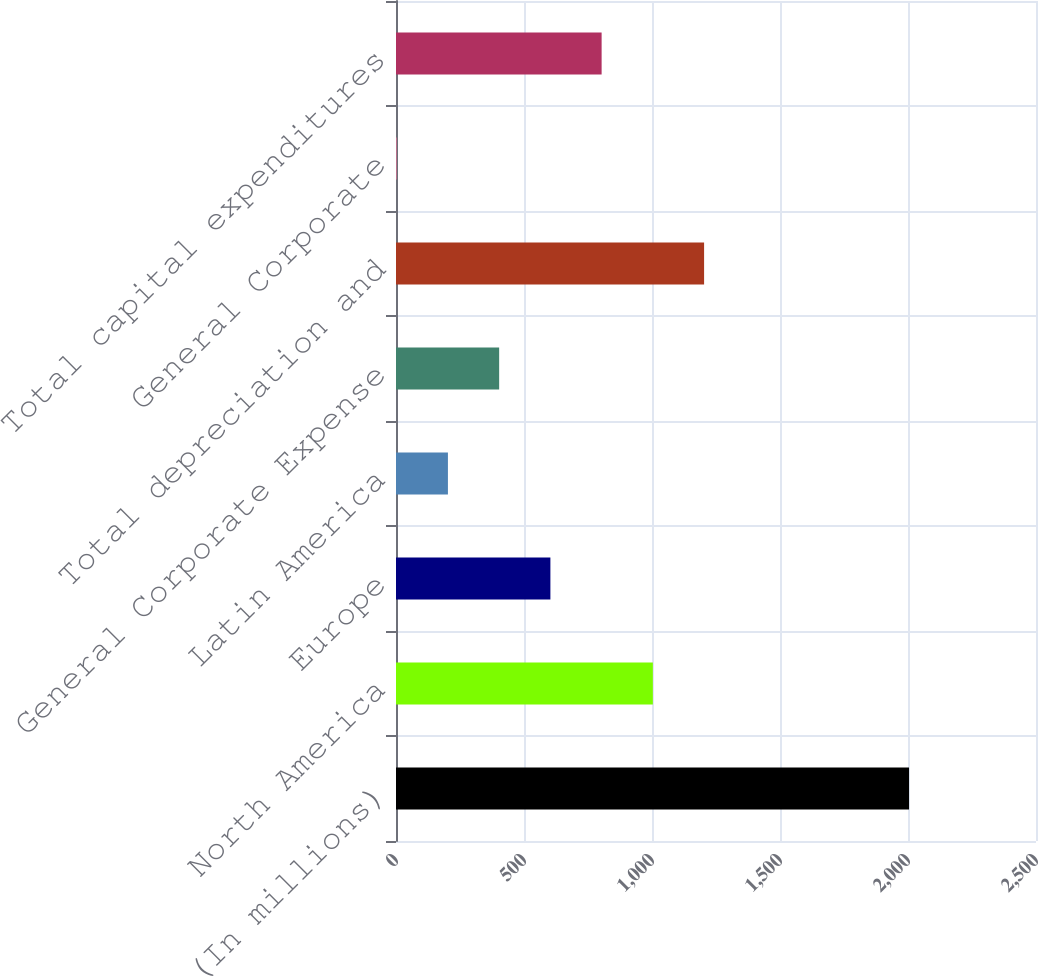Convert chart to OTSL. <chart><loc_0><loc_0><loc_500><loc_500><bar_chart><fcel>(In millions)<fcel>North America<fcel>Europe<fcel>Latin America<fcel>General Corporate Expense<fcel>Total depreciation and<fcel>General Corporate<fcel>Total capital expenditures<nl><fcel>2004<fcel>1003.35<fcel>603.09<fcel>202.83<fcel>402.96<fcel>1203.48<fcel>2.7<fcel>803.22<nl></chart> 